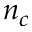Convert formula to latex. <formula><loc_0><loc_0><loc_500><loc_500>n _ { c }</formula> 